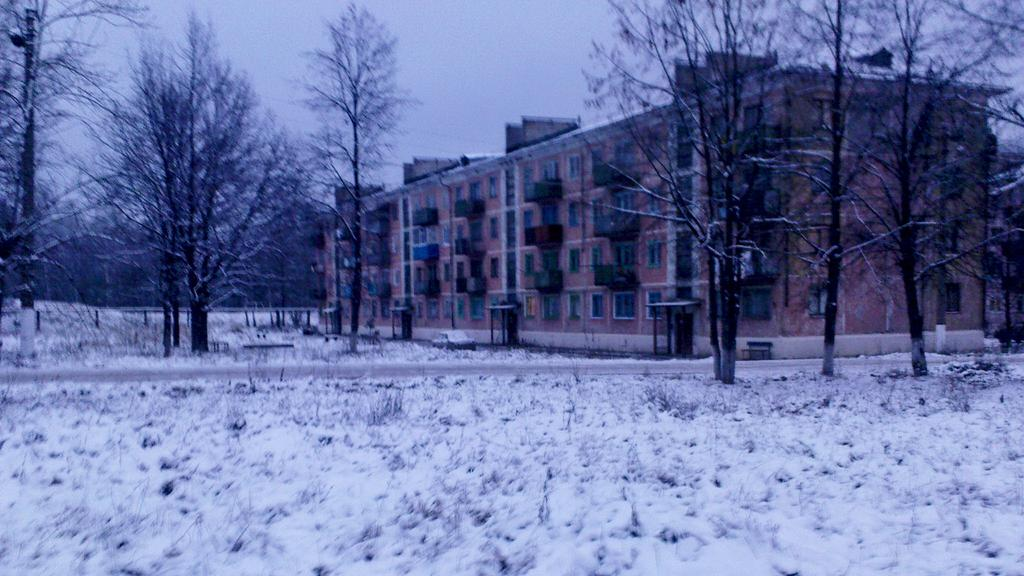What is the main structure visible in the image? There is a building in the image. What is located in front of the building? There are many trees in front of the building. What is the ground covered with at the bottom of the image? There is snow on the ground at the bottom of the image. What type of cream can be seen being applied to the brass in the image? There is no cream or brass present in the image; it features a building with trees and snow on the ground. 